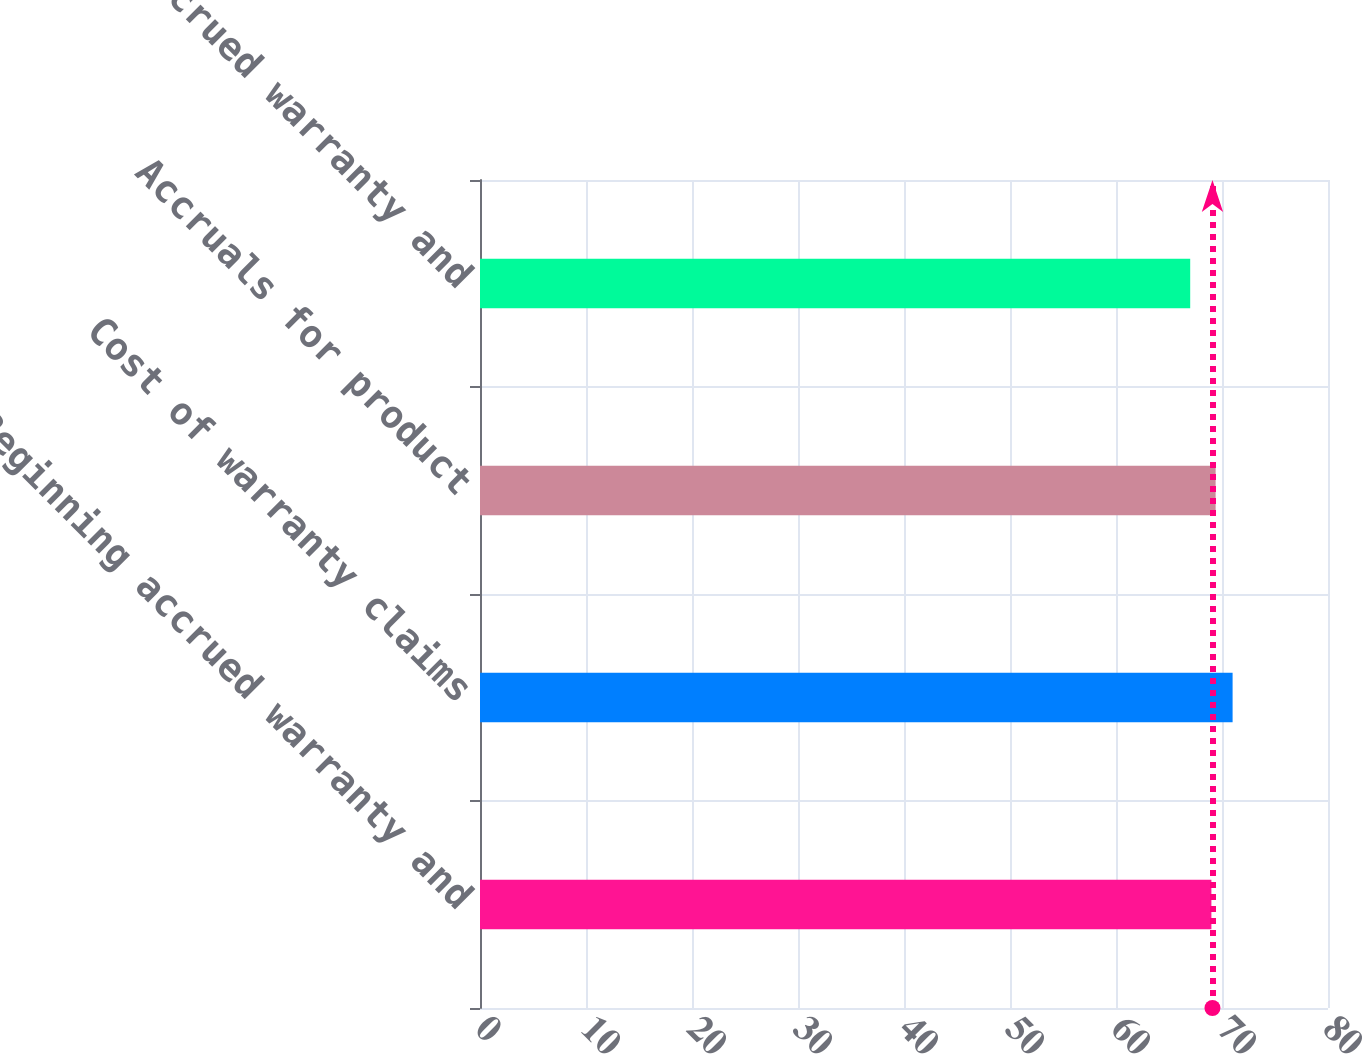Convert chart to OTSL. <chart><loc_0><loc_0><loc_500><loc_500><bar_chart><fcel>Beginning accrued warranty and<fcel>Cost of warranty claims<fcel>Accruals for product<fcel>Ending accrued warranty and<nl><fcel>69<fcel>71<fcel>69.4<fcel>67<nl></chart> 